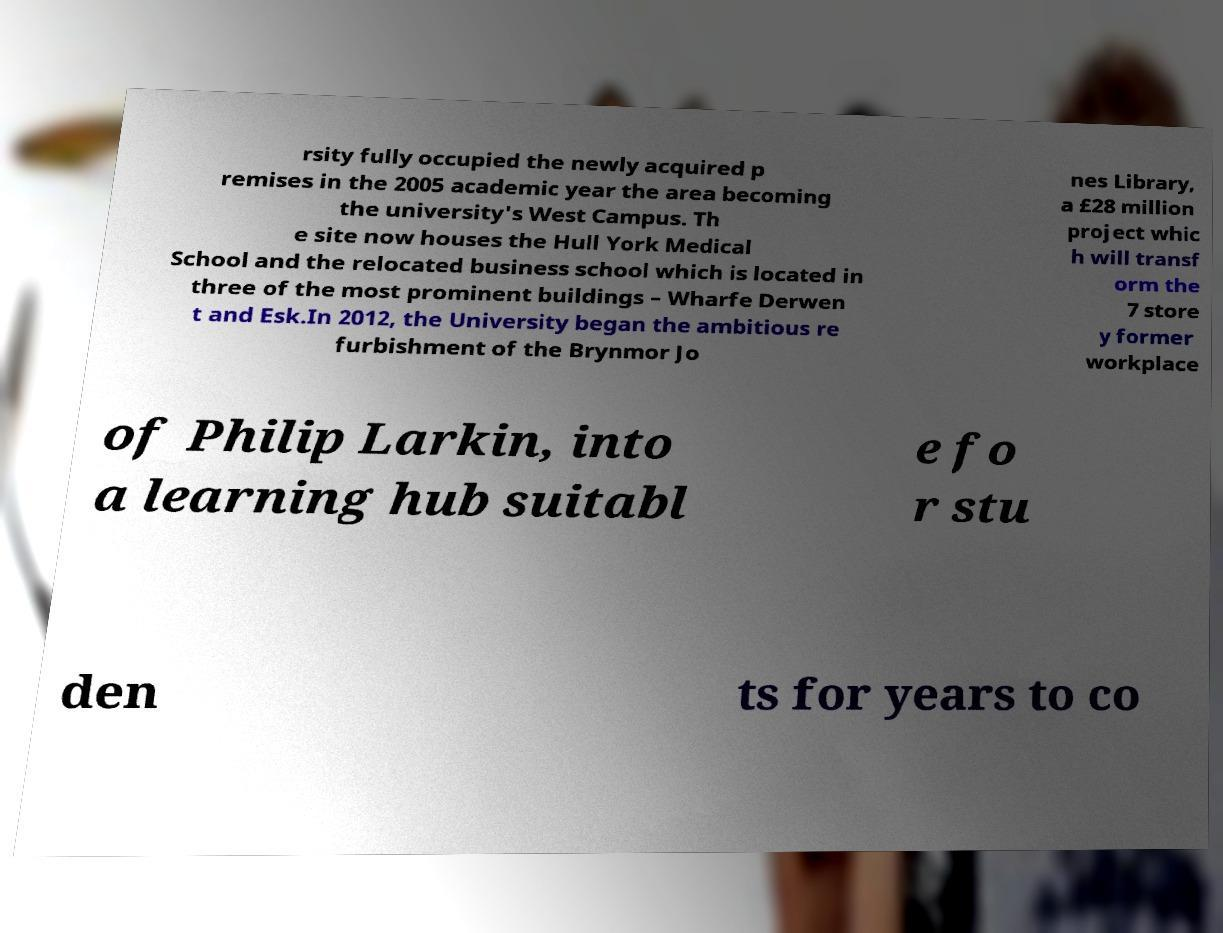For documentation purposes, I need the text within this image transcribed. Could you provide that? rsity fully occupied the newly acquired p remises in the 2005 academic year the area becoming the university's West Campus. Th e site now houses the Hull York Medical School and the relocated business school which is located in three of the most prominent buildings – Wharfe Derwen t and Esk.In 2012, the University began the ambitious re furbishment of the Brynmor Jo nes Library, a £28 million project whic h will transf orm the 7 store y former workplace of Philip Larkin, into a learning hub suitabl e fo r stu den ts for years to co 